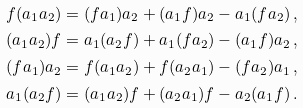<formula> <loc_0><loc_0><loc_500><loc_500>f ( a _ { 1 } a _ { 2 } ) & = ( f a _ { 1 } ) a _ { 2 } + ( a _ { 1 } f ) a _ { 2 } - a _ { 1 } ( f a _ { 2 } ) \, , \\ ( a _ { 1 } a _ { 2 } ) f & = a _ { 1 } ( a _ { 2 } f ) + a _ { 1 } ( f a _ { 2 } ) - ( a _ { 1 } f ) a _ { 2 } \, , \\ ( f a _ { 1 } ) a _ { 2 } & = f ( a _ { 1 } a _ { 2 } ) + f ( a _ { 2 } a _ { 1 } ) - ( f a _ { 2 } ) a _ { 1 } \, , \\ a _ { 1 } ( a _ { 2 } f ) & = ( a _ { 1 } a _ { 2 } ) f + ( a _ { 2 } a _ { 1 } ) f - a _ { 2 } ( a _ { 1 } f ) \, .</formula> 